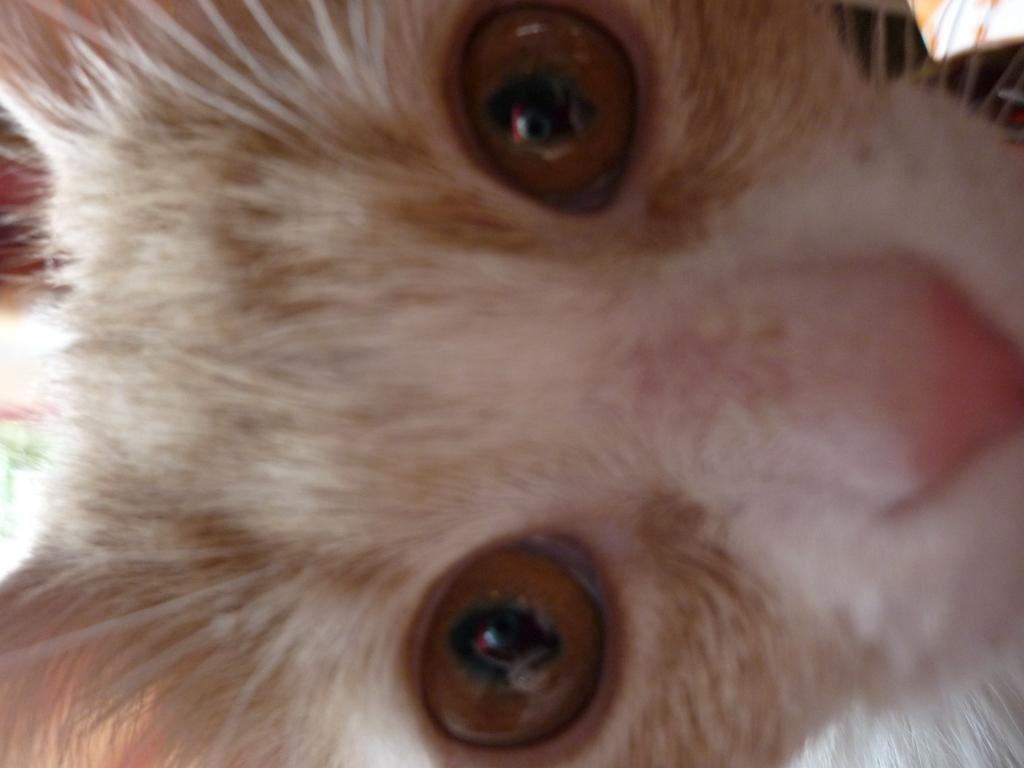What type of living creature is present in the image? There is an animal in the image. What type of vessel is being used to cast the animal in the image? There is no vessel or casting process depicted in the image; it simply features an animal. 